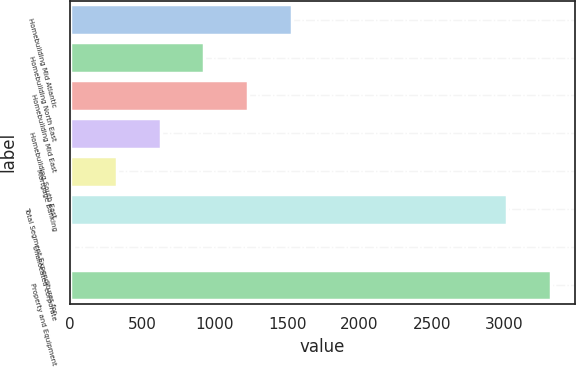<chart> <loc_0><loc_0><loc_500><loc_500><bar_chart><fcel>Homebuilding Mid Atlantic<fcel>Homebuilding North East<fcel>Homebuilding Mid East<fcel>Homebuilding South East<fcel>Mortgage Banking<fcel>Total Segment Expenditures for<fcel>Unallocated corporate<fcel>Property and Equipment<nl><fcel>1533<fcel>928.6<fcel>1230.8<fcel>626.4<fcel>324.2<fcel>3022<fcel>22<fcel>3324.2<nl></chart> 